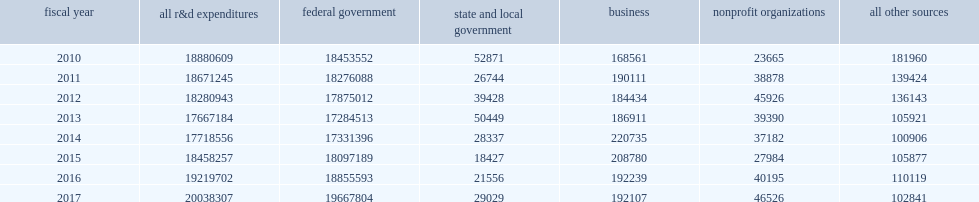Would you mind parsing the complete table? {'header': ['fiscal year', 'all r&d expenditures', 'federal government', 'state and local government', 'business', 'nonprofit organizations', 'all other sources'], 'rows': [['2010', '18880609', '18453552', '52871', '168561', '23665', '181960'], ['2011', '18671245', '18276088', '26744', '190111', '38878', '139424'], ['2012', '18280943', '17875012', '39428', '184434', '45926', '136143'], ['2013', '17667184', '17284513', '50449', '186911', '39390', '105921'], ['2014', '17718556', '17331396', '28337', '220735', '37182', '100906'], ['2015', '18458257', '18097189', '18427', '208780', '27984', '105877'], ['2016', '19219702', '18855593', '21556', '192239', '40195', '110119'], ['2017', '20038307', '19667804', '29029', '192107', '46526', '102841']]} How many thousand dollars did the nation's 42 federally funded research and development centers (ffrdcs) spend on r&d in fy 2017? 20038307.0. How many percentage points did most support for r&d come from the federal government in fy 2017? 0.98151. Most support for r&d came from the federal government, how many thousand dollars reached in fy 2017? 19667804.0. 